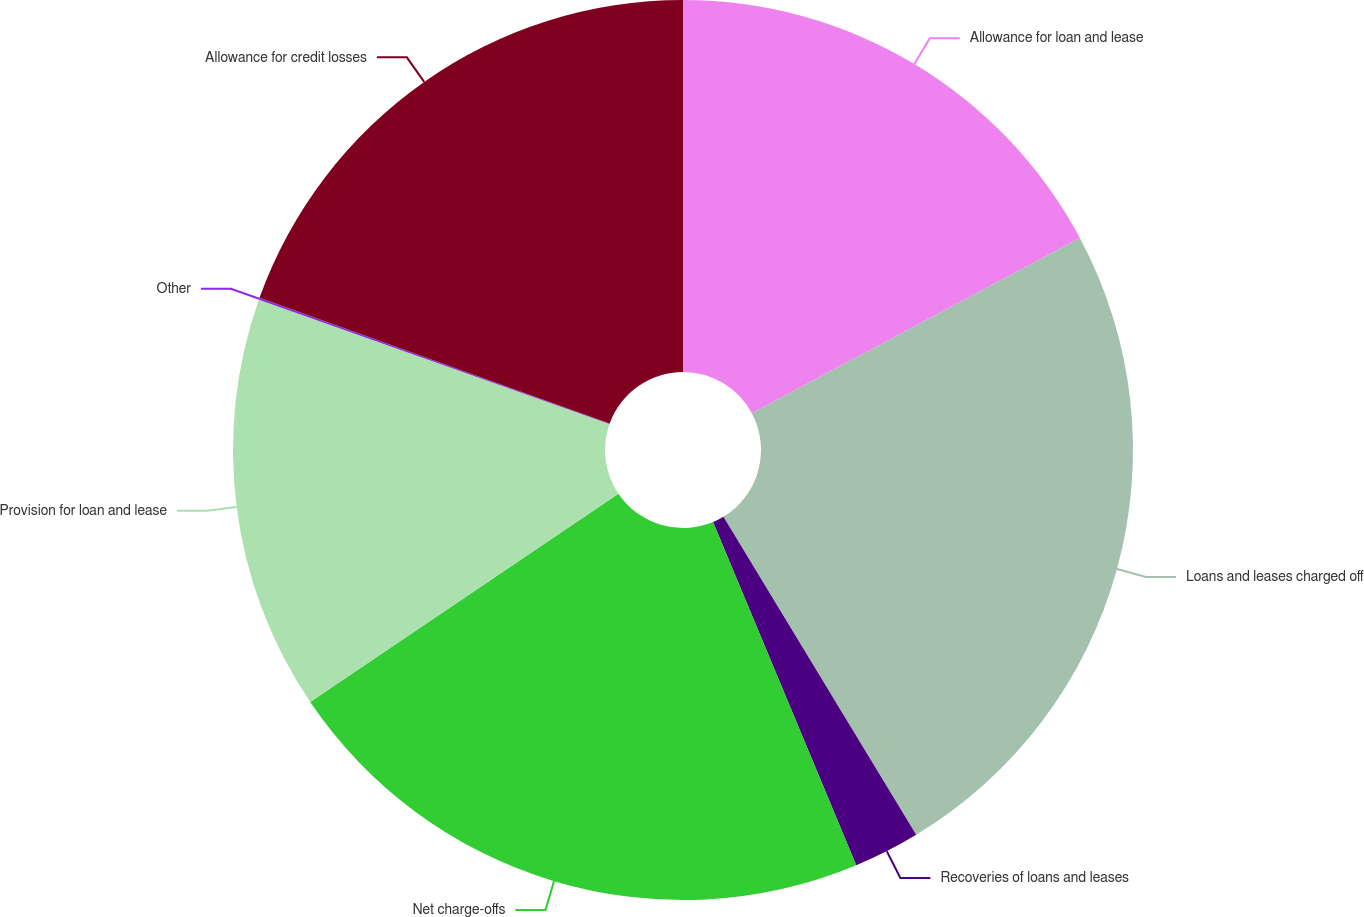Convert chart. <chart><loc_0><loc_0><loc_500><loc_500><pie_chart><fcel>Allowance for loan and lease<fcel>Loans and leases charged off<fcel>Recoveries of loans and leases<fcel>Net charge-offs<fcel>Provision for loan and lease<fcel>Other<fcel>Allowance for credit losses<nl><fcel>17.19%<fcel>24.14%<fcel>2.38%<fcel>21.83%<fcel>14.88%<fcel>0.07%<fcel>19.51%<nl></chart> 